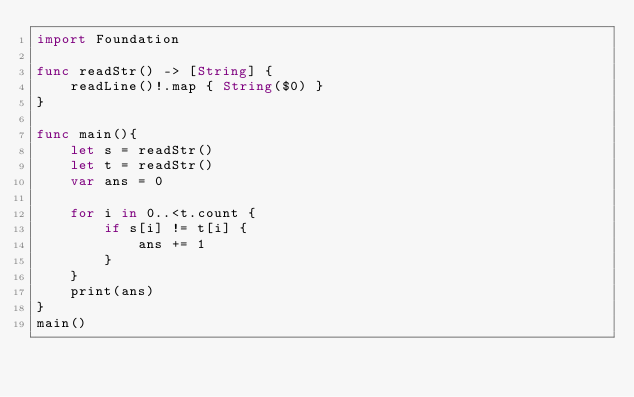Convert code to text. <code><loc_0><loc_0><loc_500><loc_500><_Swift_>import Foundation

func readStr() -> [String] {
    readLine()!.map { String($0) }
}

func main(){
    let s = readStr()
    let t = readStr()
    var ans = 0
    
    for i in 0..<t.count {
        if s[i] != t[i] {
            ans += 1
        }
    }
    print(ans)
}
main()

</code> 